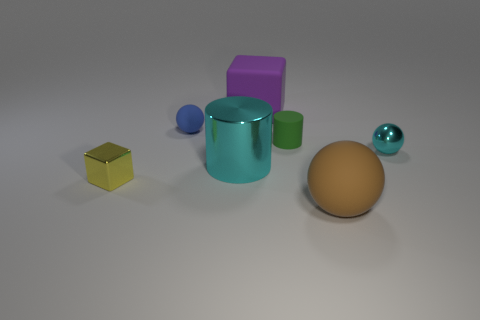There is a tiny metal thing that is the same color as the big cylinder; what shape is it?
Make the answer very short. Sphere. What number of gray things are either metallic spheres or shiny blocks?
Your answer should be compact. 0. What is the shape of the cyan metallic thing on the left side of the brown rubber ball?
Your answer should be very brief. Cylinder. There is a ball that is the same size as the purple block; what is its color?
Your response must be concise. Brown. Does the large cyan metal object have the same shape as the big matte thing right of the big purple matte cube?
Offer a terse response. No. There is a big cyan cylinder in front of the tiny rubber thing that is in front of the small blue object behind the tiny green thing; what is its material?
Make the answer very short. Metal. How many small things are either purple balls or yellow blocks?
Your answer should be very brief. 1. What number of other objects are there of the same size as the purple thing?
Your response must be concise. 2. Is the shape of the tiny rubber thing to the left of the purple cube the same as  the small cyan object?
Your answer should be very brief. Yes. There is another thing that is the same shape as the big cyan thing; what is its color?
Your answer should be very brief. Green. 